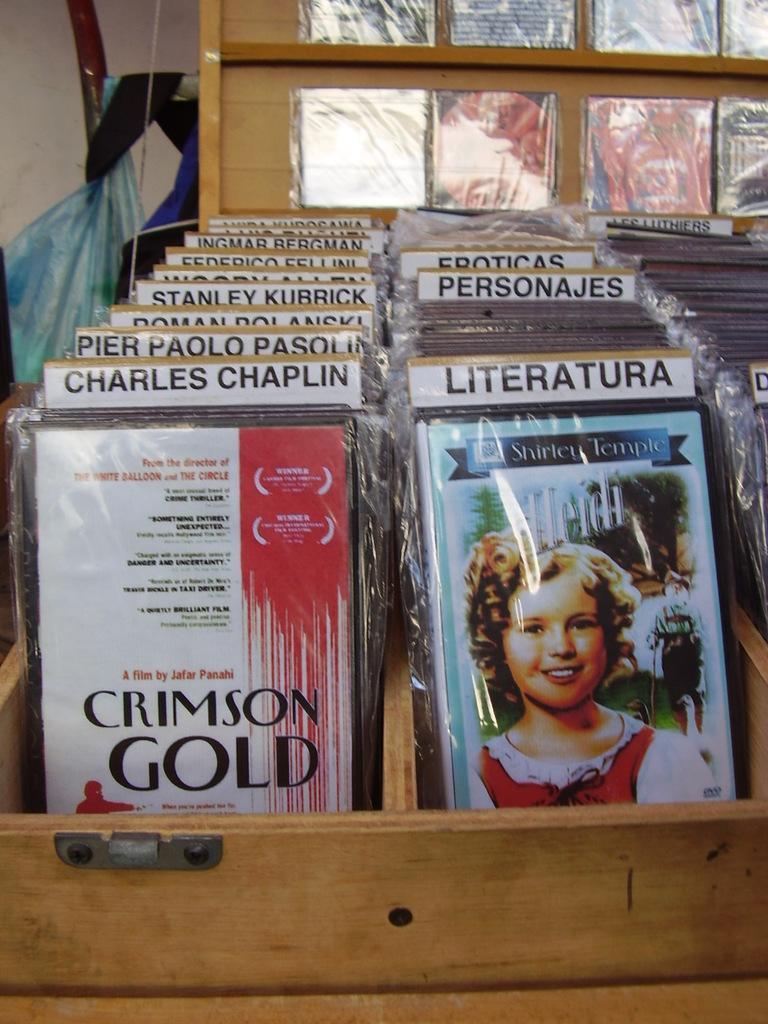Could you give a brief overview of what you see in this image? In this image there are books placed on the wooden boxes. 